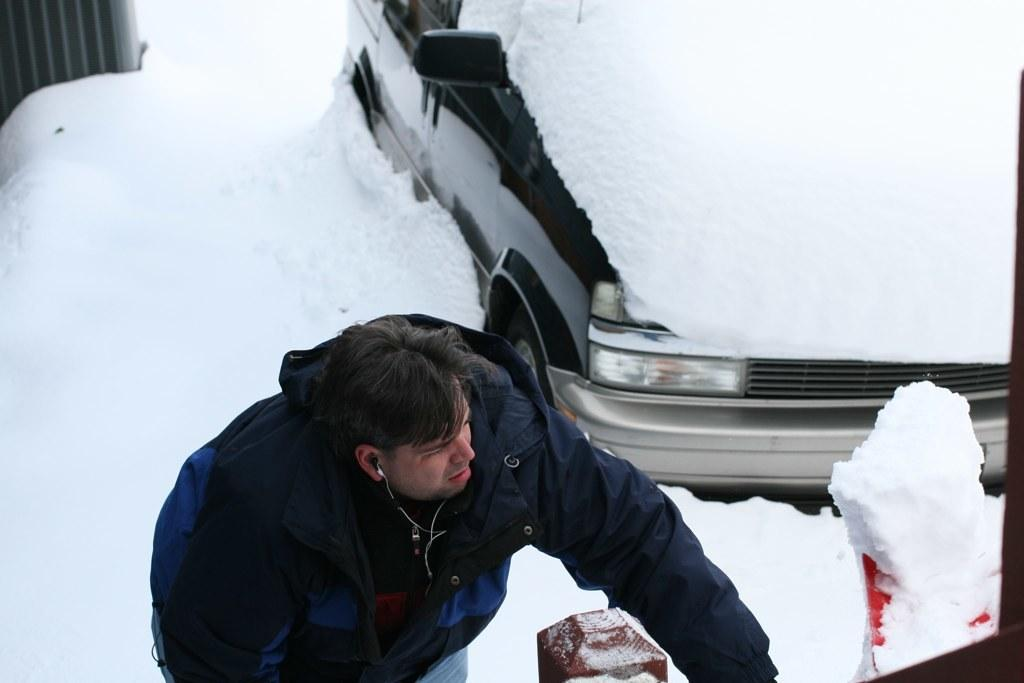Who is present in the image? There is a man in the image. What is the man wearing? The man is wearing a jacket. What can be seen in the man's ear? The man has an earphone in his ear. What is visible in the background of the image? There is a vehicle and snow visible in the background of the image. What type of jeans is the man wearing in the image? The provided facts do not mention the man wearing jeans, so we cannot determine the type of jeans he is wearing. 